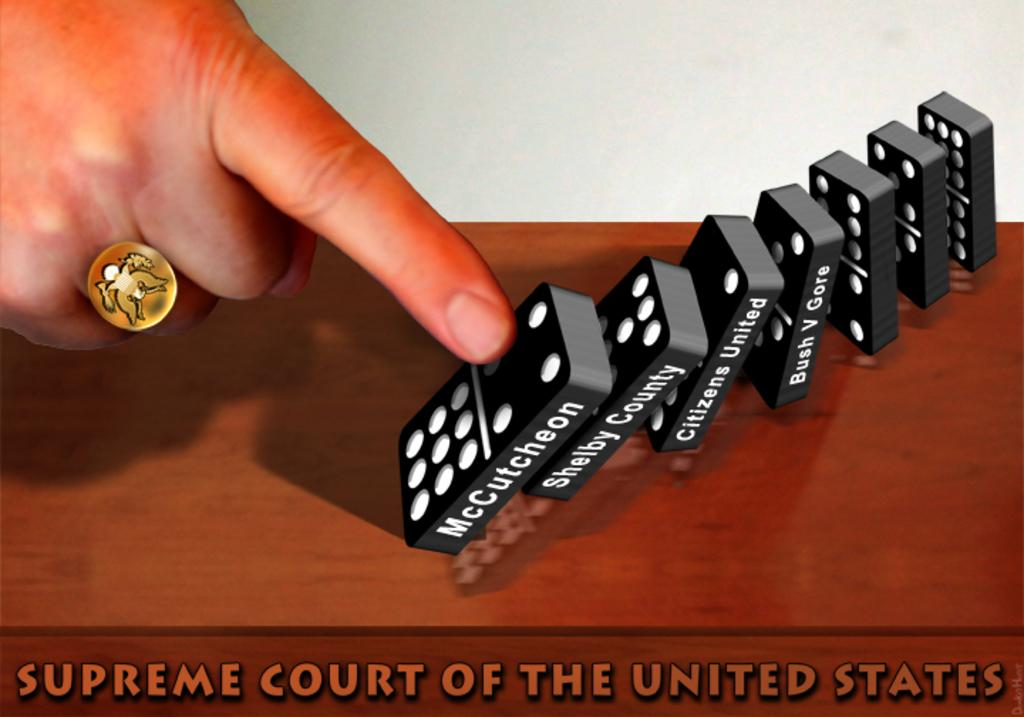<image>
Render a clear and concise summary of the photo. Supreme Court of the United States is written across the side of the table. 